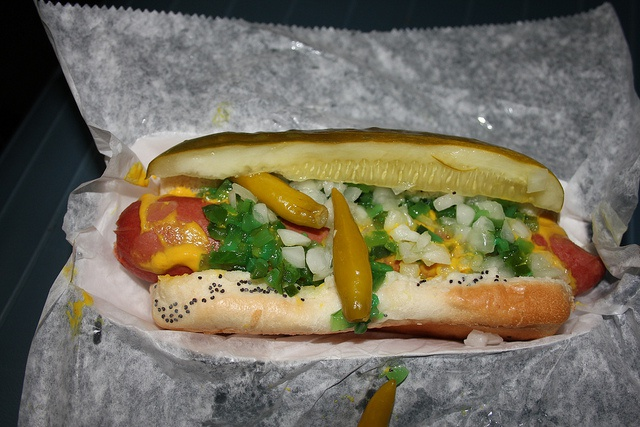Describe the objects in this image and their specific colors. I can see a hot dog in black, tan, olive, and maroon tones in this image. 